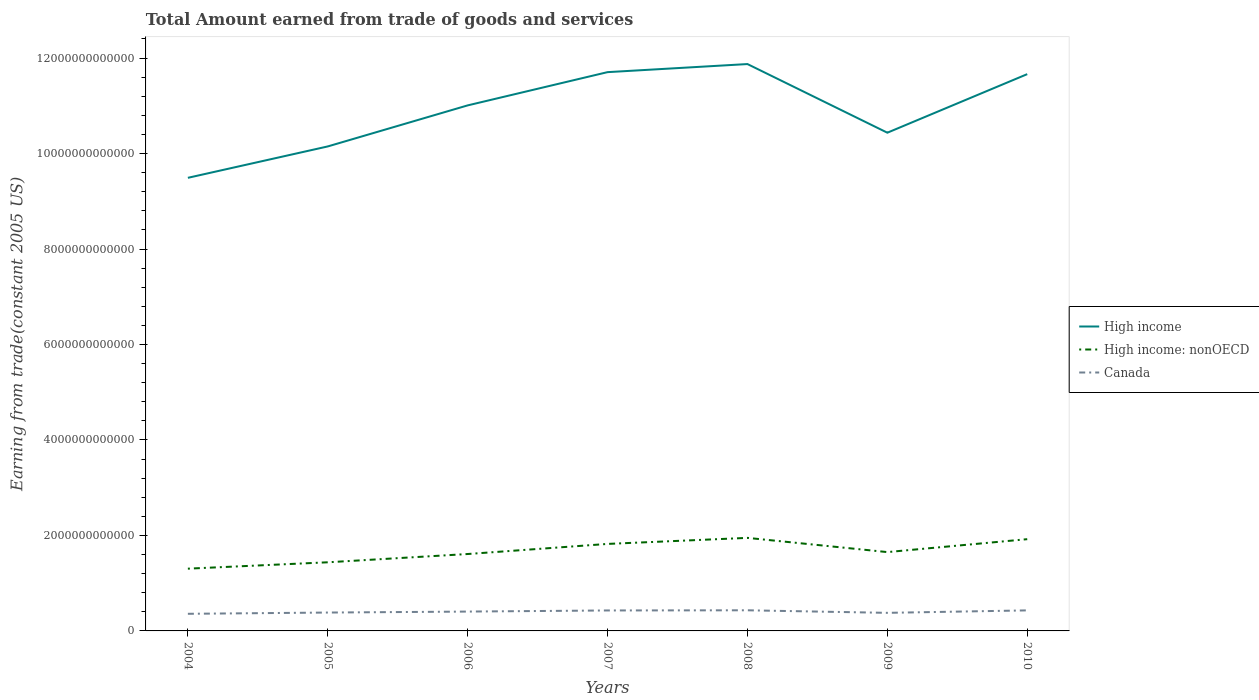How many different coloured lines are there?
Make the answer very short. 3. Is the number of lines equal to the number of legend labels?
Provide a succinct answer. Yes. Across all years, what is the maximum total amount earned by trading goods and services in High income: nonOECD?
Your answer should be very brief. 1.30e+12. What is the total total amount earned by trading goods and services in High income in the graph?
Ensure brevity in your answer.  -1.56e+12. What is the difference between the highest and the second highest total amount earned by trading goods and services in Canada?
Keep it short and to the point. 7.35e+1. Is the total amount earned by trading goods and services in Canada strictly greater than the total amount earned by trading goods and services in High income: nonOECD over the years?
Keep it short and to the point. Yes. How many lines are there?
Your answer should be very brief. 3. How many years are there in the graph?
Ensure brevity in your answer.  7. What is the difference between two consecutive major ticks on the Y-axis?
Make the answer very short. 2.00e+12. Does the graph contain any zero values?
Offer a very short reply. No. Where does the legend appear in the graph?
Your response must be concise. Center right. How many legend labels are there?
Offer a terse response. 3. What is the title of the graph?
Your answer should be very brief. Total Amount earned from trade of goods and services. What is the label or title of the Y-axis?
Offer a very short reply. Earning from trade(constant 2005 US). What is the Earning from trade(constant 2005 US) of High income in 2004?
Make the answer very short. 9.49e+12. What is the Earning from trade(constant 2005 US) in High income: nonOECD in 2004?
Provide a short and direct response. 1.30e+12. What is the Earning from trade(constant 2005 US) in Canada in 2004?
Make the answer very short. 3.59e+11. What is the Earning from trade(constant 2005 US) in High income in 2005?
Make the answer very short. 1.01e+13. What is the Earning from trade(constant 2005 US) of High income: nonOECD in 2005?
Offer a terse response. 1.44e+12. What is the Earning from trade(constant 2005 US) in Canada in 2005?
Your response must be concise. 3.85e+11. What is the Earning from trade(constant 2005 US) of High income in 2006?
Make the answer very short. 1.10e+13. What is the Earning from trade(constant 2005 US) of High income: nonOECD in 2006?
Offer a very short reply. 1.61e+12. What is the Earning from trade(constant 2005 US) in Canada in 2006?
Make the answer very short. 4.05e+11. What is the Earning from trade(constant 2005 US) of High income in 2007?
Make the answer very short. 1.17e+13. What is the Earning from trade(constant 2005 US) in High income: nonOECD in 2007?
Provide a short and direct response. 1.82e+12. What is the Earning from trade(constant 2005 US) in Canada in 2007?
Make the answer very short. 4.29e+11. What is the Earning from trade(constant 2005 US) in High income in 2008?
Keep it short and to the point. 1.19e+13. What is the Earning from trade(constant 2005 US) of High income: nonOECD in 2008?
Keep it short and to the point. 1.95e+12. What is the Earning from trade(constant 2005 US) of Canada in 2008?
Ensure brevity in your answer.  4.32e+11. What is the Earning from trade(constant 2005 US) in High income in 2009?
Provide a short and direct response. 1.04e+13. What is the Earning from trade(constant 2005 US) of High income: nonOECD in 2009?
Your answer should be compact. 1.65e+12. What is the Earning from trade(constant 2005 US) of Canada in 2009?
Your answer should be very brief. 3.79e+11. What is the Earning from trade(constant 2005 US) of High income in 2010?
Keep it short and to the point. 1.17e+13. What is the Earning from trade(constant 2005 US) in High income: nonOECD in 2010?
Ensure brevity in your answer.  1.92e+12. What is the Earning from trade(constant 2005 US) in Canada in 2010?
Make the answer very short. 4.30e+11. Across all years, what is the maximum Earning from trade(constant 2005 US) of High income?
Offer a terse response. 1.19e+13. Across all years, what is the maximum Earning from trade(constant 2005 US) of High income: nonOECD?
Your answer should be compact. 1.95e+12. Across all years, what is the maximum Earning from trade(constant 2005 US) in Canada?
Your answer should be compact. 4.32e+11. Across all years, what is the minimum Earning from trade(constant 2005 US) in High income?
Your response must be concise. 9.49e+12. Across all years, what is the minimum Earning from trade(constant 2005 US) of High income: nonOECD?
Your answer should be very brief. 1.30e+12. Across all years, what is the minimum Earning from trade(constant 2005 US) of Canada?
Give a very brief answer. 3.59e+11. What is the total Earning from trade(constant 2005 US) of High income in the graph?
Offer a very short reply. 7.63e+13. What is the total Earning from trade(constant 2005 US) of High income: nonOECD in the graph?
Give a very brief answer. 1.17e+13. What is the total Earning from trade(constant 2005 US) in Canada in the graph?
Provide a succinct answer. 2.82e+12. What is the difference between the Earning from trade(constant 2005 US) in High income in 2004 and that in 2005?
Ensure brevity in your answer.  -6.58e+11. What is the difference between the Earning from trade(constant 2005 US) in High income: nonOECD in 2004 and that in 2005?
Provide a succinct answer. -1.34e+11. What is the difference between the Earning from trade(constant 2005 US) in Canada in 2004 and that in 2005?
Make the answer very short. -2.62e+1. What is the difference between the Earning from trade(constant 2005 US) of High income in 2004 and that in 2006?
Ensure brevity in your answer.  -1.52e+12. What is the difference between the Earning from trade(constant 2005 US) of High income: nonOECD in 2004 and that in 2006?
Give a very brief answer. -3.07e+11. What is the difference between the Earning from trade(constant 2005 US) of Canada in 2004 and that in 2006?
Provide a succinct answer. -4.66e+1. What is the difference between the Earning from trade(constant 2005 US) in High income in 2004 and that in 2007?
Keep it short and to the point. -2.21e+12. What is the difference between the Earning from trade(constant 2005 US) of High income: nonOECD in 2004 and that in 2007?
Your answer should be compact. -5.19e+11. What is the difference between the Earning from trade(constant 2005 US) in Canada in 2004 and that in 2007?
Offer a terse response. -7.00e+1. What is the difference between the Earning from trade(constant 2005 US) of High income in 2004 and that in 2008?
Provide a short and direct response. -2.38e+12. What is the difference between the Earning from trade(constant 2005 US) of High income: nonOECD in 2004 and that in 2008?
Offer a very short reply. -6.45e+11. What is the difference between the Earning from trade(constant 2005 US) of Canada in 2004 and that in 2008?
Provide a short and direct response. -7.35e+1. What is the difference between the Earning from trade(constant 2005 US) of High income in 2004 and that in 2009?
Offer a very short reply. -9.45e+11. What is the difference between the Earning from trade(constant 2005 US) of High income: nonOECD in 2004 and that in 2009?
Ensure brevity in your answer.  -3.47e+11. What is the difference between the Earning from trade(constant 2005 US) of Canada in 2004 and that in 2009?
Your answer should be very brief. -2.00e+1. What is the difference between the Earning from trade(constant 2005 US) of High income in 2004 and that in 2010?
Offer a very short reply. -2.17e+12. What is the difference between the Earning from trade(constant 2005 US) of High income: nonOECD in 2004 and that in 2010?
Offer a terse response. -6.18e+11. What is the difference between the Earning from trade(constant 2005 US) of Canada in 2004 and that in 2010?
Your answer should be very brief. -7.16e+1. What is the difference between the Earning from trade(constant 2005 US) in High income in 2005 and that in 2006?
Your response must be concise. -8.60e+11. What is the difference between the Earning from trade(constant 2005 US) in High income: nonOECD in 2005 and that in 2006?
Your response must be concise. -1.73e+11. What is the difference between the Earning from trade(constant 2005 US) of Canada in 2005 and that in 2006?
Make the answer very short. -2.04e+1. What is the difference between the Earning from trade(constant 2005 US) of High income in 2005 and that in 2007?
Your answer should be compact. -1.56e+12. What is the difference between the Earning from trade(constant 2005 US) of High income: nonOECD in 2005 and that in 2007?
Your answer should be compact. -3.85e+11. What is the difference between the Earning from trade(constant 2005 US) of Canada in 2005 and that in 2007?
Ensure brevity in your answer.  -4.37e+1. What is the difference between the Earning from trade(constant 2005 US) in High income in 2005 and that in 2008?
Offer a terse response. -1.73e+12. What is the difference between the Earning from trade(constant 2005 US) of High income: nonOECD in 2005 and that in 2008?
Provide a short and direct response. -5.12e+11. What is the difference between the Earning from trade(constant 2005 US) in Canada in 2005 and that in 2008?
Your answer should be very brief. -4.72e+1. What is the difference between the Earning from trade(constant 2005 US) in High income in 2005 and that in 2009?
Your answer should be very brief. -2.88e+11. What is the difference between the Earning from trade(constant 2005 US) of High income: nonOECD in 2005 and that in 2009?
Your response must be concise. -2.14e+11. What is the difference between the Earning from trade(constant 2005 US) in Canada in 2005 and that in 2009?
Your answer should be compact. 6.20e+09. What is the difference between the Earning from trade(constant 2005 US) in High income in 2005 and that in 2010?
Provide a short and direct response. -1.51e+12. What is the difference between the Earning from trade(constant 2005 US) of High income: nonOECD in 2005 and that in 2010?
Give a very brief answer. -4.84e+11. What is the difference between the Earning from trade(constant 2005 US) in Canada in 2005 and that in 2010?
Give a very brief answer. -4.54e+1. What is the difference between the Earning from trade(constant 2005 US) of High income in 2006 and that in 2007?
Provide a short and direct response. -6.96e+11. What is the difference between the Earning from trade(constant 2005 US) in High income: nonOECD in 2006 and that in 2007?
Ensure brevity in your answer.  -2.12e+11. What is the difference between the Earning from trade(constant 2005 US) of Canada in 2006 and that in 2007?
Offer a very short reply. -2.33e+1. What is the difference between the Earning from trade(constant 2005 US) of High income in 2006 and that in 2008?
Your answer should be compact. -8.66e+11. What is the difference between the Earning from trade(constant 2005 US) of High income: nonOECD in 2006 and that in 2008?
Your answer should be compact. -3.38e+11. What is the difference between the Earning from trade(constant 2005 US) of Canada in 2006 and that in 2008?
Your answer should be compact. -2.68e+1. What is the difference between the Earning from trade(constant 2005 US) of High income in 2006 and that in 2009?
Ensure brevity in your answer.  5.72e+11. What is the difference between the Earning from trade(constant 2005 US) in High income: nonOECD in 2006 and that in 2009?
Your answer should be very brief. -4.04e+1. What is the difference between the Earning from trade(constant 2005 US) of Canada in 2006 and that in 2009?
Ensure brevity in your answer.  2.66e+1. What is the difference between the Earning from trade(constant 2005 US) of High income in 2006 and that in 2010?
Provide a short and direct response. -6.54e+11. What is the difference between the Earning from trade(constant 2005 US) in High income: nonOECD in 2006 and that in 2010?
Offer a terse response. -3.11e+11. What is the difference between the Earning from trade(constant 2005 US) of Canada in 2006 and that in 2010?
Keep it short and to the point. -2.50e+1. What is the difference between the Earning from trade(constant 2005 US) of High income in 2007 and that in 2008?
Offer a very short reply. -1.69e+11. What is the difference between the Earning from trade(constant 2005 US) of High income: nonOECD in 2007 and that in 2008?
Make the answer very short. -1.27e+11. What is the difference between the Earning from trade(constant 2005 US) in Canada in 2007 and that in 2008?
Your answer should be very brief. -3.50e+09. What is the difference between the Earning from trade(constant 2005 US) of High income in 2007 and that in 2009?
Your answer should be very brief. 1.27e+12. What is the difference between the Earning from trade(constant 2005 US) in High income: nonOECD in 2007 and that in 2009?
Keep it short and to the point. 1.71e+11. What is the difference between the Earning from trade(constant 2005 US) in Canada in 2007 and that in 2009?
Ensure brevity in your answer.  4.99e+1. What is the difference between the Earning from trade(constant 2005 US) in High income in 2007 and that in 2010?
Your answer should be compact. 4.20e+1. What is the difference between the Earning from trade(constant 2005 US) in High income: nonOECD in 2007 and that in 2010?
Make the answer very short. -9.91e+1. What is the difference between the Earning from trade(constant 2005 US) of Canada in 2007 and that in 2010?
Ensure brevity in your answer.  -1.65e+09. What is the difference between the Earning from trade(constant 2005 US) of High income in 2008 and that in 2009?
Your answer should be compact. 1.44e+12. What is the difference between the Earning from trade(constant 2005 US) in High income: nonOECD in 2008 and that in 2009?
Your response must be concise. 2.98e+11. What is the difference between the Earning from trade(constant 2005 US) of Canada in 2008 and that in 2009?
Keep it short and to the point. 5.34e+1. What is the difference between the Earning from trade(constant 2005 US) of High income in 2008 and that in 2010?
Offer a very short reply. 2.11e+11. What is the difference between the Earning from trade(constant 2005 US) of High income: nonOECD in 2008 and that in 2010?
Offer a very short reply. 2.75e+1. What is the difference between the Earning from trade(constant 2005 US) of Canada in 2008 and that in 2010?
Your answer should be very brief. 1.85e+09. What is the difference between the Earning from trade(constant 2005 US) in High income in 2009 and that in 2010?
Offer a very short reply. -1.23e+12. What is the difference between the Earning from trade(constant 2005 US) of High income: nonOECD in 2009 and that in 2010?
Offer a terse response. -2.70e+11. What is the difference between the Earning from trade(constant 2005 US) of Canada in 2009 and that in 2010?
Give a very brief answer. -5.16e+1. What is the difference between the Earning from trade(constant 2005 US) in High income in 2004 and the Earning from trade(constant 2005 US) in High income: nonOECD in 2005?
Provide a succinct answer. 8.05e+12. What is the difference between the Earning from trade(constant 2005 US) in High income in 2004 and the Earning from trade(constant 2005 US) in Canada in 2005?
Provide a succinct answer. 9.11e+12. What is the difference between the Earning from trade(constant 2005 US) in High income: nonOECD in 2004 and the Earning from trade(constant 2005 US) in Canada in 2005?
Give a very brief answer. 9.19e+11. What is the difference between the Earning from trade(constant 2005 US) in High income in 2004 and the Earning from trade(constant 2005 US) in High income: nonOECD in 2006?
Ensure brevity in your answer.  7.88e+12. What is the difference between the Earning from trade(constant 2005 US) of High income in 2004 and the Earning from trade(constant 2005 US) of Canada in 2006?
Your response must be concise. 9.09e+12. What is the difference between the Earning from trade(constant 2005 US) in High income: nonOECD in 2004 and the Earning from trade(constant 2005 US) in Canada in 2006?
Make the answer very short. 8.99e+11. What is the difference between the Earning from trade(constant 2005 US) of High income in 2004 and the Earning from trade(constant 2005 US) of High income: nonOECD in 2007?
Offer a terse response. 7.67e+12. What is the difference between the Earning from trade(constant 2005 US) of High income in 2004 and the Earning from trade(constant 2005 US) of Canada in 2007?
Give a very brief answer. 9.06e+12. What is the difference between the Earning from trade(constant 2005 US) in High income: nonOECD in 2004 and the Earning from trade(constant 2005 US) in Canada in 2007?
Make the answer very short. 8.75e+11. What is the difference between the Earning from trade(constant 2005 US) in High income in 2004 and the Earning from trade(constant 2005 US) in High income: nonOECD in 2008?
Your answer should be very brief. 7.54e+12. What is the difference between the Earning from trade(constant 2005 US) of High income in 2004 and the Earning from trade(constant 2005 US) of Canada in 2008?
Give a very brief answer. 9.06e+12. What is the difference between the Earning from trade(constant 2005 US) of High income: nonOECD in 2004 and the Earning from trade(constant 2005 US) of Canada in 2008?
Keep it short and to the point. 8.72e+11. What is the difference between the Earning from trade(constant 2005 US) of High income in 2004 and the Earning from trade(constant 2005 US) of High income: nonOECD in 2009?
Offer a very short reply. 7.84e+12. What is the difference between the Earning from trade(constant 2005 US) in High income in 2004 and the Earning from trade(constant 2005 US) in Canada in 2009?
Keep it short and to the point. 9.11e+12. What is the difference between the Earning from trade(constant 2005 US) of High income: nonOECD in 2004 and the Earning from trade(constant 2005 US) of Canada in 2009?
Offer a terse response. 9.25e+11. What is the difference between the Earning from trade(constant 2005 US) in High income in 2004 and the Earning from trade(constant 2005 US) in High income: nonOECD in 2010?
Keep it short and to the point. 7.57e+12. What is the difference between the Earning from trade(constant 2005 US) of High income in 2004 and the Earning from trade(constant 2005 US) of Canada in 2010?
Your response must be concise. 9.06e+12. What is the difference between the Earning from trade(constant 2005 US) of High income: nonOECD in 2004 and the Earning from trade(constant 2005 US) of Canada in 2010?
Your response must be concise. 8.74e+11. What is the difference between the Earning from trade(constant 2005 US) in High income in 2005 and the Earning from trade(constant 2005 US) in High income: nonOECD in 2006?
Make the answer very short. 8.54e+12. What is the difference between the Earning from trade(constant 2005 US) of High income in 2005 and the Earning from trade(constant 2005 US) of Canada in 2006?
Give a very brief answer. 9.74e+12. What is the difference between the Earning from trade(constant 2005 US) of High income: nonOECD in 2005 and the Earning from trade(constant 2005 US) of Canada in 2006?
Ensure brevity in your answer.  1.03e+12. What is the difference between the Earning from trade(constant 2005 US) in High income in 2005 and the Earning from trade(constant 2005 US) in High income: nonOECD in 2007?
Provide a short and direct response. 8.33e+12. What is the difference between the Earning from trade(constant 2005 US) of High income in 2005 and the Earning from trade(constant 2005 US) of Canada in 2007?
Your response must be concise. 9.72e+12. What is the difference between the Earning from trade(constant 2005 US) in High income: nonOECD in 2005 and the Earning from trade(constant 2005 US) in Canada in 2007?
Provide a short and direct response. 1.01e+12. What is the difference between the Earning from trade(constant 2005 US) of High income in 2005 and the Earning from trade(constant 2005 US) of High income: nonOECD in 2008?
Your answer should be very brief. 8.20e+12. What is the difference between the Earning from trade(constant 2005 US) of High income in 2005 and the Earning from trade(constant 2005 US) of Canada in 2008?
Make the answer very short. 9.72e+12. What is the difference between the Earning from trade(constant 2005 US) of High income: nonOECD in 2005 and the Earning from trade(constant 2005 US) of Canada in 2008?
Give a very brief answer. 1.01e+12. What is the difference between the Earning from trade(constant 2005 US) of High income in 2005 and the Earning from trade(constant 2005 US) of High income: nonOECD in 2009?
Provide a succinct answer. 8.50e+12. What is the difference between the Earning from trade(constant 2005 US) in High income in 2005 and the Earning from trade(constant 2005 US) in Canada in 2009?
Make the answer very short. 9.77e+12. What is the difference between the Earning from trade(constant 2005 US) in High income: nonOECD in 2005 and the Earning from trade(constant 2005 US) in Canada in 2009?
Ensure brevity in your answer.  1.06e+12. What is the difference between the Earning from trade(constant 2005 US) in High income in 2005 and the Earning from trade(constant 2005 US) in High income: nonOECD in 2010?
Your answer should be compact. 8.23e+12. What is the difference between the Earning from trade(constant 2005 US) of High income in 2005 and the Earning from trade(constant 2005 US) of Canada in 2010?
Make the answer very short. 9.72e+12. What is the difference between the Earning from trade(constant 2005 US) of High income: nonOECD in 2005 and the Earning from trade(constant 2005 US) of Canada in 2010?
Provide a succinct answer. 1.01e+12. What is the difference between the Earning from trade(constant 2005 US) in High income in 2006 and the Earning from trade(constant 2005 US) in High income: nonOECD in 2007?
Offer a very short reply. 9.19e+12. What is the difference between the Earning from trade(constant 2005 US) in High income in 2006 and the Earning from trade(constant 2005 US) in Canada in 2007?
Make the answer very short. 1.06e+13. What is the difference between the Earning from trade(constant 2005 US) in High income: nonOECD in 2006 and the Earning from trade(constant 2005 US) in Canada in 2007?
Your answer should be compact. 1.18e+12. What is the difference between the Earning from trade(constant 2005 US) in High income in 2006 and the Earning from trade(constant 2005 US) in High income: nonOECD in 2008?
Keep it short and to the point. 9.06e+12. What is the difference between the Earning from trade(constant 2005 US) in High income in 2006 and the Earning from trade(constant 2005 US) in Canada in 2008?
Ensure brevity in your answer.  1.06e+13. What is the difference between the Earning from trade(constant 2005 US) in High income: nonOECD in 2006 and the Earning from trade(constant 2005 US) in Canada in 2008?
Provide a short and direct response. 1.18e+12. What is the difference between the Earning from trade(constant 2005 US) of High income in 2006 and the Earning from trade(constant 2005 US) of High income: nonOECD in 2009?
Make the answer very short. 9.36e+12. What is the difference between the Earning from trade(constant 2005 US) in High income in 2006 and the Earning from trade(constant 2005 US) in Canada in 2009?
Ensure brevity in your answer.  1.06e+13. What is the difference between the Earning from trade(constant 2005 US) of High income: nonOECD in 2006 and the Earning from trade(constant 2005 US) of Canada in 2009?
Offer a terse response. 1.23e+12. What is the difference between the Earning from trade(constant 2005 US) in High income in 2006 and the Earning from trade(constant 2005 US) in High income: nonOECD in 2010?
Make the answer very short. 9.09e+12. What is the difference between the Earning from trade(constant 2005 US) in High income in 2006 and the Earning from trade(constant 2005 US) in Canada in 2010?
Give a very brief answer. 1.06e+13. What is the difference between the Earning from trade(constant 2005 US) of High income: nonOECD in 2006 and the Earning from trade(constant 2005 US) of Canada in 2010?
Ensure brevity in your answer.  1.18e+12. What is the difference between the Earning from trade(constant 2005 US) in High income in 2007 and the Earning from trade(constant 2005 US) in High income: nonOECD in 2008?
Offer a very short reply. 9.76e+12. What is the difference between the Earning from trade(constant 2005 US) in High income in 2007 and the Earning from trade(constant 2005 US) in Canada in 2008?
Give a very brief answer. 1.13e+13. What is the difference between the Earning from trade(constant 2005 US) in High income: nonOECD in 2007 and the Earning from trade(constant 2005 US) in Canada in 2008?
Ensure brevity in your answer.  1.39e+12. What is the difference between the Earning from trade(constant 2005 US) of High income in 2007 and the Earning from trade(constant 2005 US) of High income: nonOECD in 2009?
Offer a very short reply. 1.01e+13. What is the difference between the Earning from trade(constant 2005 US) of High income in 2007 and the Earning from trade(constant 2005 US) of Canada in 2009?
Offer a very short reply. 1.13e+13. What is the difference between the Earning from trade(constant 2005 US) of High income: nonOECD in 2007 and the Earning from trade(constant 2005 US) of Canada in 2009?
Offer a very short reply. 1.44e+12. What is the difference between the Earning from trade(constant 2005 US) of High income in 2007 and the Earning from trade(constant 2005 US) of High income: nonOECD in 2010?
Your response must be concise. 9.78e+12. What is the difference between the Earning from trade(constant 2005 US) in High income in 2007 and the Earning from trade(constant 2005 US) in Canada in 2010?
Give a very brief answer. 1.13e+13. What is the difference between the Earning from trade(constant 2005 US) in High income: nonOECD in 2007 and the Earning from trade(constant 2005 US) in Canada in 2010?
Your response must be concise. 1.39e+12. What is the difference between the Earning from trade(constant 2005 US) of High income in 2008 and the Earning from trade(constant 2005 US) of High income: nonOECD in 2009?
Ensure brevity in your answer.  1.02e+13. What is the difference between the Earning from trade(constant 2005 US) in High income in 2008 and the Earning from trade(constant 2005 US) in Canada in 2009?
Provide a short and direct response. 1.15e+13. What is the difference between the Earning from trade(constant 2005 US) in High income: nonOECD in 2008 and the Earning from trade(constant 2005 US) in Canada in 2009?
Offer a terse response. 1.57e+12. What is the difference between the Earning from trade(constant 2005 US) of High income in 2008 and the Earning from trade(constant 2005 US) of High income: nonOECD in 2010?
Give a very brief answer. 9.95e+12. What is the difference between the Earning from trade(constant 2005 US) in High income in 2008 and the Earning from trade(constant 2005 US) in Canada in 2010?
Make the answer very short. 1.14e+13. What is the difference between the Earning from trade(constant 2005 US) in High income: nonOECD in 2008 and the Earning from trade(constant 2005 US) in Canada in 2010?
Your answer should be compact. 1.52e+12. What is the difference between the Earning from trade(constant 2005 US) of High income in 2009 and the Earning from trade(constant 2005 US) of High income: nonOECD in 2010?
Keep it short and to the point. 8.52e+12. What is the difference between the Earning from trade(constant 2005 US) of High income in 2009 and the Earning from trade(constant 2005 US) of Canada in 2010?
Your response must be concise. 1.00e+13. What is the difference between the Earning from trade(constant 2005 US) of High income: nonOECD in 2009 and the Earning from trade(constant 2005 US) of Canada in 2010?
Offer a very short reply. 1.22e+12. What is the average Earning from trade(constant 2005 US) of High income per year?
Your response must be concise. 1.09e+13. What is the average Earning from trade(constant 2005 US) of High income: nonOECD per year?
Ensure brevity in your answer.  1.67e+12. What is the average Earning from trade(constant 2005 US) of Canada per year?
Make the answer very short. 4.03e+11. In the year 2004, what is the difference between the Earning from trade(constant 2005 US) of High income and Earning from trade(constant 2005 US) of High income: nonOECD?
Your answer should be very brief. 8.19e+12. In the year 2004, what is the difference between the Earning from trade(constant 2005 US) in High income and Earning from trade(constant 2005 US) in Canada?
Keep it short and to the point. 9.13e+12. In the year 2004, what is the difference between the Earning from trade(constant 2005 US) in High income: nonOECD and Earning from trade(constant 2005 US) in Canada?
Your answer should be very brief. 9.45e+11. In the year 2005, what is the difference between the Earning from trade(constant 2005 US) in High income and Earning from trade(constant 2005 US) in High income: nonOECD?
Offer a terse response. 8.71e+12. In the year 2005, what is the difference between the Earning from trade(constant 2005 US) of High income and Earning from trade(constant 2005 US) of Canada?
Ensure brevity in your answer.  9.76e+12. In the year 2005, what is the difference between the Earning from trade(constant 2005 US) in High income: nonOECD and Earning from trade(constant 2005 US) in Canada?
Keep it short and to the point. 1.05e+12. In the year 2006, what is the difference between the Earning from trade(constant 2005 US) in High income and Earning from trade(constant 2005 US) in High income: nonOECD?
Make the answer very short. 9.40e+12. In the year 2006, what is the difference between the Earning from trade(constant 2005 US) of High income and Earning from trade(constant 2005 US) of Canada?
Make the answer very short. 1.06e+13. In the year 2006, what is the difference between the Earning from trade(constant 2005 US) in High income: nonOECD and Earning from trade(constant 2005 US) in Canada?
Your response must be concise. 1.21e+12. In the year 2007, what is the difference between the Earning from trade(constant 2005 US) of High income and Earning from trade(constant 2005 US) of High income: nonOECD?
Give a very brief answer. 9.88e+12. In the year 2007, what is the difference between the Earning from trade(constant 2005 US) of High income and Earning from trade(constant 2005 US) of Canada?
Offer a terse response. 1.13e+13. In the year 2007, what is the difference between the Earning from trade(constant 2005 US) in High income: nonOECD and Earning from trade(constant 2005 US) in Canada?
Your answer should be compact. 1.39e+12. In the year 2008, what is the difference between the Earning from trade(constant 2005 US) in High income and Earning from trade(constant 2005 US) in High income: nonOECD?
Provide a short and direct response. 9.93e+12. In the year 2008, what is the difference between the Earning from trade(constant 2005 US) of High income and Earning from trade(constant 2005 US) of Canada?
Provide a short and direct response. 1.14e+13. In the year 2008, what is the difference between the Earning from trade(constant 2005 US) in High income: nonOECD and Earning from trade(constant 2005 US) in Canada?
Give a very brief answer. 1.52e+12. In the year 2009, what is the difference between the Earning from trade(constant 2005 US) of High income and Earning from trade(constant 2005 US) of High income: nonOECD?
Keep it short and to the point. 8.79e+12. In the year 2009, what is the difference between the Earning from trade(constant 2005 US) in High income and Earning from trade(constant 2005 US) in Canada?
Keep it short and to the point. 1.01e+13. In the year 2009, what is the difference between the Earning from trade(constant 2005 US) of High income: nonOECD and Earning from trade(constant 2005 US) of Canada?
Provide a short and direct response. 1.27e+12. In the year 2010, what is the difference between the Earning from trade(constant 2005 US) in High income and Earning from trade(constant 2005 US) in High income: nonOECD?
Keep it short and to the point. 9.74e+12. In the year 2010, what is the difference between the Earning from trade(constant 2005 US) of High income and Earning from trade(constant 2005 US) of Canada?
Make the answer very short. 1.12e+13. In the year 2010, what is the difference between the Earning from trade(constant 2005 US) in High income: nonOECD and Earning from trade(constant 2005 US) in Canada?
Give a very brief answer. 1.49e+12. What is the ratio of the Earning from trade(constant 2005 US) in High income in 2004 to that in 2005?
Give a very brief answer. 0.94. What is the ratio of the Earning from trade(constant 2005 US) in High income: nonOECD in 2004 to that in 2005?
Your response must be concise. 0.91. What is the ratio of the Earning from trade(constant 2005 US) of Canada in 2004 to that in 2005?
Keep it short and to the point. 0.93. What is the ratio of the Earning from trade(constant 2005 US) in High income in 2004 to that in 2006?
Keep it short and to the point. 0.86. What is the ratio of the Earning from trade(constant 2005 US) in High income: nonOECD in 2004 to that in 2006?
Give a very brief answer. 0.81. What is the ratio of the Earning from trade(constant 2005 US) in Canada in 2004 to that in 2006?
Offer a very short reply. 0.88. What is the ratio of the Earning from trade(constant 2005 US) in High income in 2004 to that in 2007?
Ensure brevity in your answer.  0.81. What is the ratio of the Earning from trade(constant 2005 US) in High income: nonOECD in 2004 to that in 2007?
Offer a terse response. 0.72. What is the ratio of the Earning from trade(constant 2005 US) of Canada in 2004 to that in 2007?
Your answer should be very brief. 0.84. What is the ratio of the Earning from trade(constant 2005 US) of High income in 2004 to that in 2008?
Ensure brevity in your answer.  0.8. What is the ratio of the Earning from trade(constant 2005 US) of High income: nonOECD in 2004 to that in 2008?
Offer a terse response. 0.67. What is the ratio of the Earning from trade(constant 2005 US) of Canada in 2004 to that in 2008?
Offer a terse response. 0.83. What is the ratio of the Earning from trade(constant 2005 US) of High income in 2004 to that in 2009?
Your answer should be very brief. 0.91. What is the ratio of the Earning from trade(constant 2005 US) in High income: nonOECD in 2004 to that in 2009?
Ensure brevity in your answer.  0.79. What is the ratio of the Earning from trade(constant 2005 US) in Canada in 2004 to that in 2009?
Your response must be concise. 0.95. What is the ratio of the Earning from trade(constant 2005 US) in High income in 2004 to that in 2010?
Your answer should be very brief. 0.81. What is the ratio of the Earning from trade(constant 2005 US) in High income: nonOECD in 2004 to that in 2010?
Give a very brief answer. 0.68. What is the ratio of the Earning from trade(constant 2005 US) of Canada in 2004 to that in 2010?
Your answer should be compact. 0.83. What is the ratio of the Earning from trade(constant 2005 US) in High income in 2005 to that in 2006?
Your response must be concise. 0.92. What is the ratio of the Earning from trade(constant 2005 US) of High income: nonOECD in 2005 to that in 2006?
Make the answer very short. 0.89. What is the ratio of the Earning from trade(constant 2005 US) of Canada in 2005 to that in 2006?
Make the answer very short. 0.95. What is the ratio of the Earning from trade(constant 2005 US) in High income in 2005 to that in 2007?
Your answer should be very brief. 0.87. What is the ratio of the Earning from trade(constant 2005 US) in High income: nonOECD in 2005 to that in 2007?
Your answer should be compact. 0.79. What is the ratio of the Earning from trade(constant 2005 US) in Canada in 2005 to that in 2007?
Provide a short and direct response. 0.9. What is the ratio of the Earning from trade(constant 2005 US) of High income in 2005 to that in 2008?
Your answer should be very brief. 0.85. What is the ratio of the Earning from trade(constant 2005 US) of High income: nonOECD in 2005 to that in 2008?
Make the answer very short. 0.74. What is the ratio of the Earning from trade(constant 2005 US) of Canada in 2005 to that in 2008?
Your answer should be very brief. 0.89. What is the ratio of the Earning from trade(constant 2005 US) of High income in 2005 to that in 2009?
Provide a short and direct response. 0.97. What is the ratio of the Earning from trade(constant 2005 US) of High income: nonOECD in 2005 to that in 2009?
Provide a succinct answer. 0.87. What is the ratio of the Earning from trade(constant 2005 US) of Canada in 2005 to that in 2009?
Make the answer very short. 1.02. What is the ratio of the Earning from trade(constant 2005 US) in High income in 2005 to that in 2010?
Provide a short and direct response. 0.87. What is the ratio of the Earning from trade(constant 2005 US) of High income: nonOECD in 2005 to that in 2010?
Offer a terse response. 0.75. What is the ratio of the Earning from trade(constant 2005 US) in Canada in 2005 to that in 2010?
Keep it short and to the point. 0.89. What is the ratio of the Earning from trade(constant 2005 US) in High income in 2006 to that in 2007?
Give a very brief answer. 0.94. What is the ratio of the Earning from trade(constant 2005 US) in High income: nonOECD in 2006 to that in 2007?
Your answer should be very brief. 0.88. What is the ratio of the Earning from trade(constant 2005 US) in Canada in 2006 to that in 2007?
Your response must be concise. 0.95. What is the ratio of the Earning from trade(constant 2005 US) in High income in 2006 to that in 2008?
Provide a succinct answer. 0.93. What is the ratio of the Earning from trade(constant 2005 US) in High income: nonOECD in 2006 to that in 2008?
Keep it short and to the point. 0.83. What is the ratio of the Earning from trade(constant 2005 US) of Canada in 2006 to that in 2008?
Your response must be concise. 0.94. What is the ratio of the Earning from trade(constant 2005 US) of High income in 2006 to that in 2009?
Offer a terse response. 1.05. What is the ratio of the Earning from trade(constant 2005 US) of High income: nonOECD in 2006 to that in 2009?
Your response must be concise. 0.98. What is the ratio of the Earning from trade(constant 2005 US) of Canada in 2006 to that in 2009?
Offer a very short reply. 1.07. What is the ratio of the Earning from trade(constant 2005 US) in High income in 2006 to that in 2010?
Make the answer very short. 0.94. What is the ratio of the Earning from trade(constant 2005 US) in High income: nonOECD in 2006 to that in 2010?
Provide a short and direct response. 0.84. What is the ratio of the Earning from trade(constant 2005 US) of Canada in 2006 to that in 2010?
Ensure brevity in your answer.  0.94. What is the ratio of the Earning from trade(constant 2005 US) of High income in 2007 to that in 2008?
Provide a short and direct response. 0.99. What is the ratio of the Earning from trade(constant 2005 US) of High income: nonOECD in 2007 to that in 2008?
Your response must be concise. 0.94. What is the ratio of the Earning from trade(constant 2005 US) in Canada in 2007 to that in 2008?
Provide a short and direct response. 0.99. What is the ratio of the Earning from trade(constant 2005 US) of High income in 2007 to that in 2009?
Make the answer very short. 1.12. What is the ratio of the Earning from trade(constant 2005 US) of High income: nonOECD in 2007 to that in 2009?
Offer a terse response. 1.1. What is the ratio of the Earning from trade(constant 2005 US) in Canada in 2007 to that in 2009?
Offer a very short reply. 1.13. What is the ratio of the Earning from trade(constant 2005 US) in High income in 2007 to that in 2010?
Your response must be concise. 1. What is the ratio of the Earning from trade(constant 2005 US) of High income: nonOECD in 2007 to that in 2010?
Offer a very short reply. 0.95. What is the ratio of the Earning from trade(constant 2005 US) in Canada in 2007 to that in 2010?
Provide a short and direct response. 1. What is the ratio of the Earning from trade(constant 2005 US) in High income in 2008 to that in 2009?
Keep it short and to the point. 1.14. What is the ratio of the Earning from trade(constant 2005 US) in High income: nonOECD in 2008 to that in 2009?
Provide a short and direct response. 1.18. What is the ratio of the Earning from trade(constant 2005 US) in Canada in 2008 to that in 2009?
Give a very brief answer. 1.14. What is the ratio of the Earning from trade(constant 2005 US) of High income in 2008 to that in 2010?
Offer a very short reply. 1.02. What is the ratio of the Earning from trade(constant 2005 US) in High income: nonOECD in 2008 to that in 2010?
Make the answer very short. 1.01. What is the ratio of the Earning from trade(constant 2005 US) in High income in 2009 to that in 2010?
Offer a terse response. 0.89. What is the ratio of the Earning from trade(constant 2005 US) of High income: nonOECD in 2009 to that in 2010?
Your answer should be compact. 0.86. What is the ratio of the Earning from trade(constant 2005 US) in Canada in 2009 to that in 2010?
Offer a terse response. 0.88. What is the difference between the highest and the second highest Earning from trade(constant 2005 US) of High income?
Make the answer very short. 1.69e+11. What is the difference between the highest and the second highest Earning from trade(constant 2005 US) of High income: nonOECD?
Offer a very short reply. 2.75e+1. What is the difference between the highest and the second highest Earning from trade(constant 2005 US) in Canada?
Provide a short and direct response. 1.85e+09. What is the difference between the highest and the lowest Earning from trade(constant 2005 US) of High income?
Provide a short and direct response. 2.38e+12. What is the difference between the highest and the lowest Earning from trade(constant 2005 US) in High income: nonOECD?
Your answer should be very brief. 6.45e+11. What is the difference between the highest and the lowest Earning from trade(constant 2005 US) in Canada?
Keep it short and to the point. 7.35e+1. 